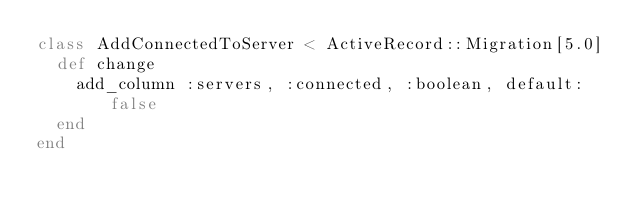<code> <loc_0><loc_0><loc_500><loc_500><_Ruby_>class AddConnectedToServer < ActiveRecord::Migration[5.0]
  def change
    add_column :servers, :connected, :boolean, default: false
  end
end
</code> 